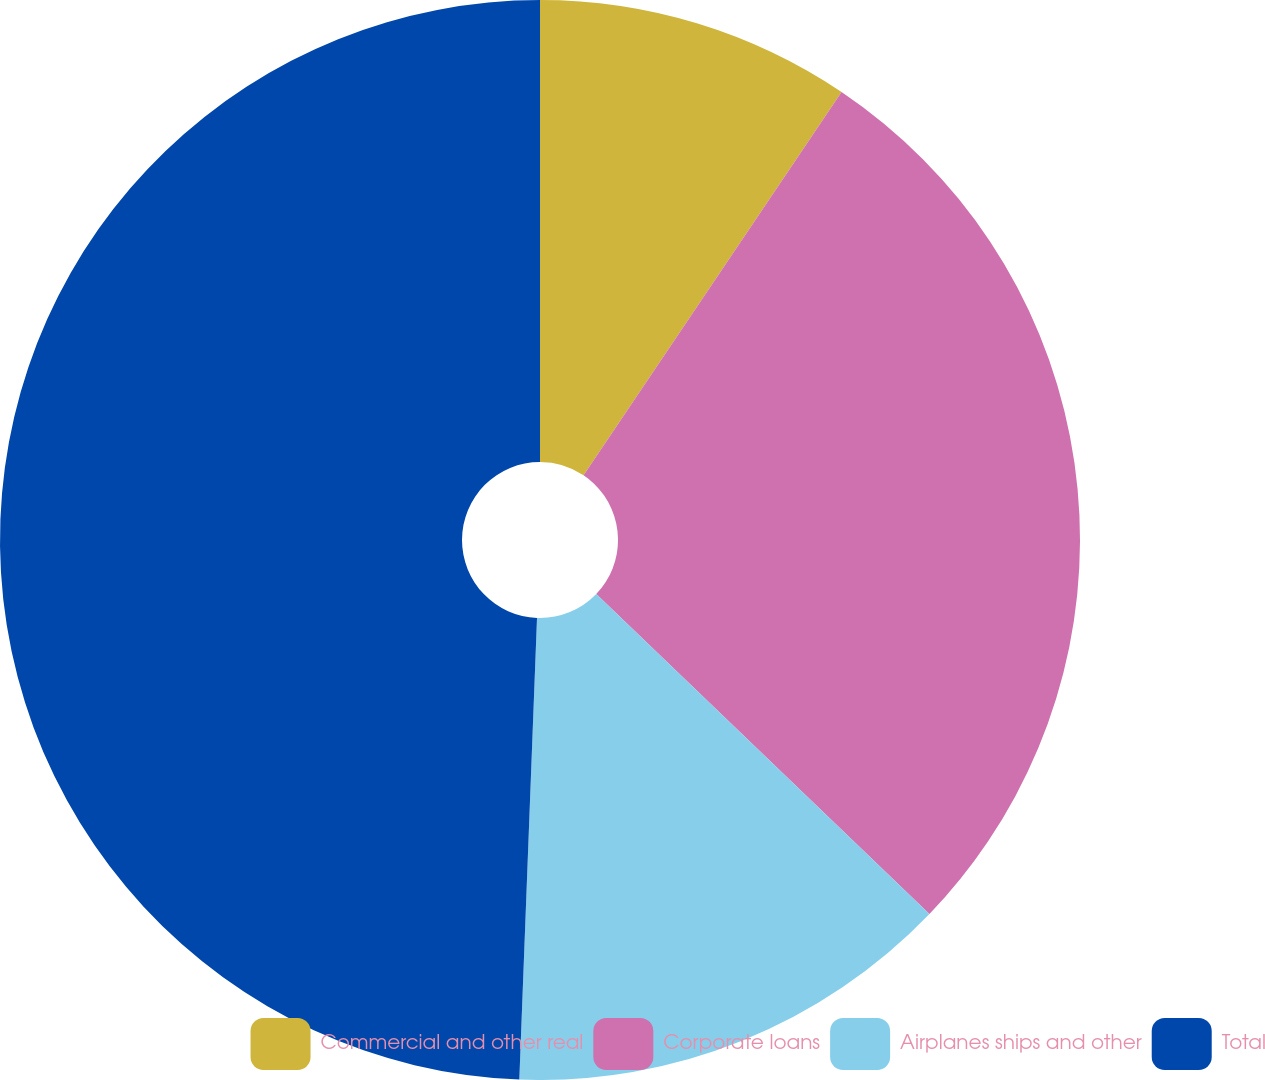<chart> <loc_0><loc_0><loc_500><loc_500><pie_chart><fcel>Commercial and other real<fcel>Corporate loans<fcel>Airplanes ships and other<fcel>Total<nl><fcel>9.43%<fcel>27.75%<fcel>13.43%<fcel>49.39%<nl></chart> 